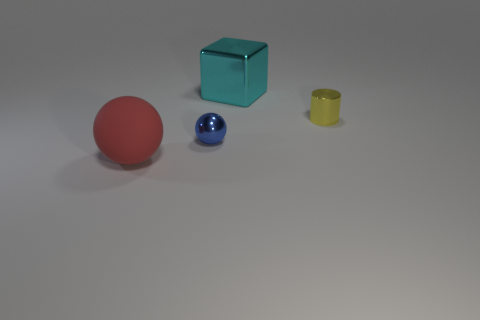Are there any objects that look like they could contain something? Yes, there is a yellow object that resembles a container or a cup, which looks like it could hold something within it. 